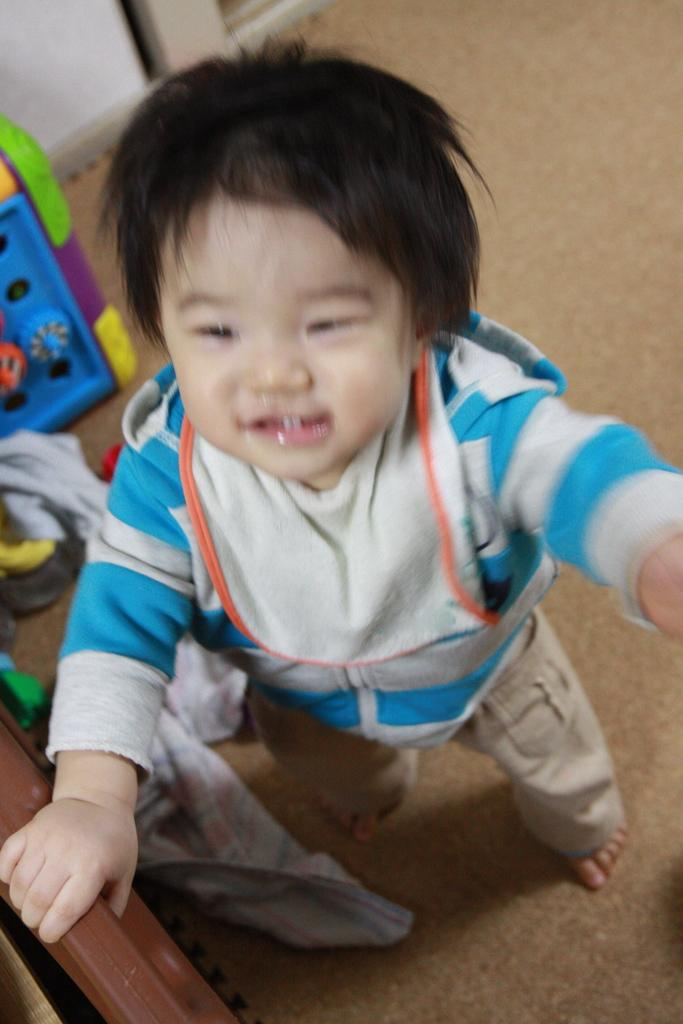What is the main subject of the image? There is a child in the image. What can be seen near the child? There are objects near the child. What is located at the bottom of the image? There is an object at the bottom of the image. What type of material is on the floor in the image? There is cloth on the floor in the image. What is visible in the background of the image? There is a wall visible in the image. How many lizards can be seen crawling on the wall in the image? There are no lizards visible in the image; only the child, objects, and wall are present. What type of slope is depicted in the image? There is no slope present in the image. 